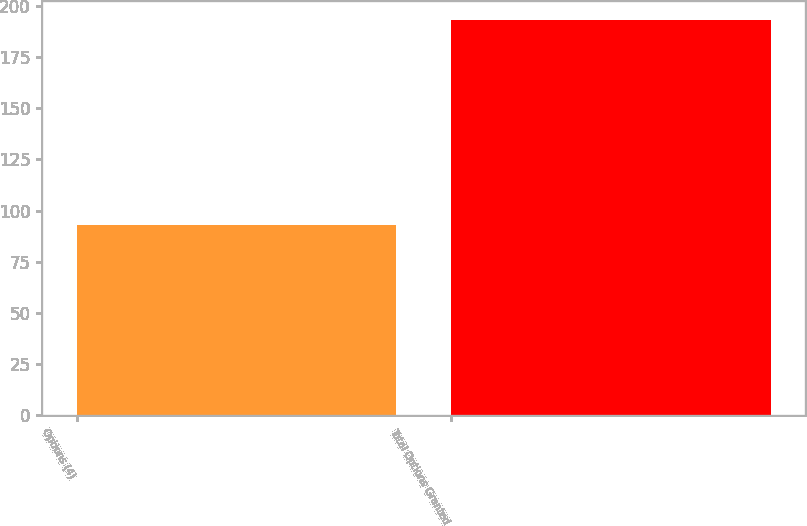<chart> <loc_0><loc_0><loc_500><loc_500><bar_chart><fcel>Options (4)<fcel>Total Options Granted<nl><fcel>93<fcel>193<nl></chart> 